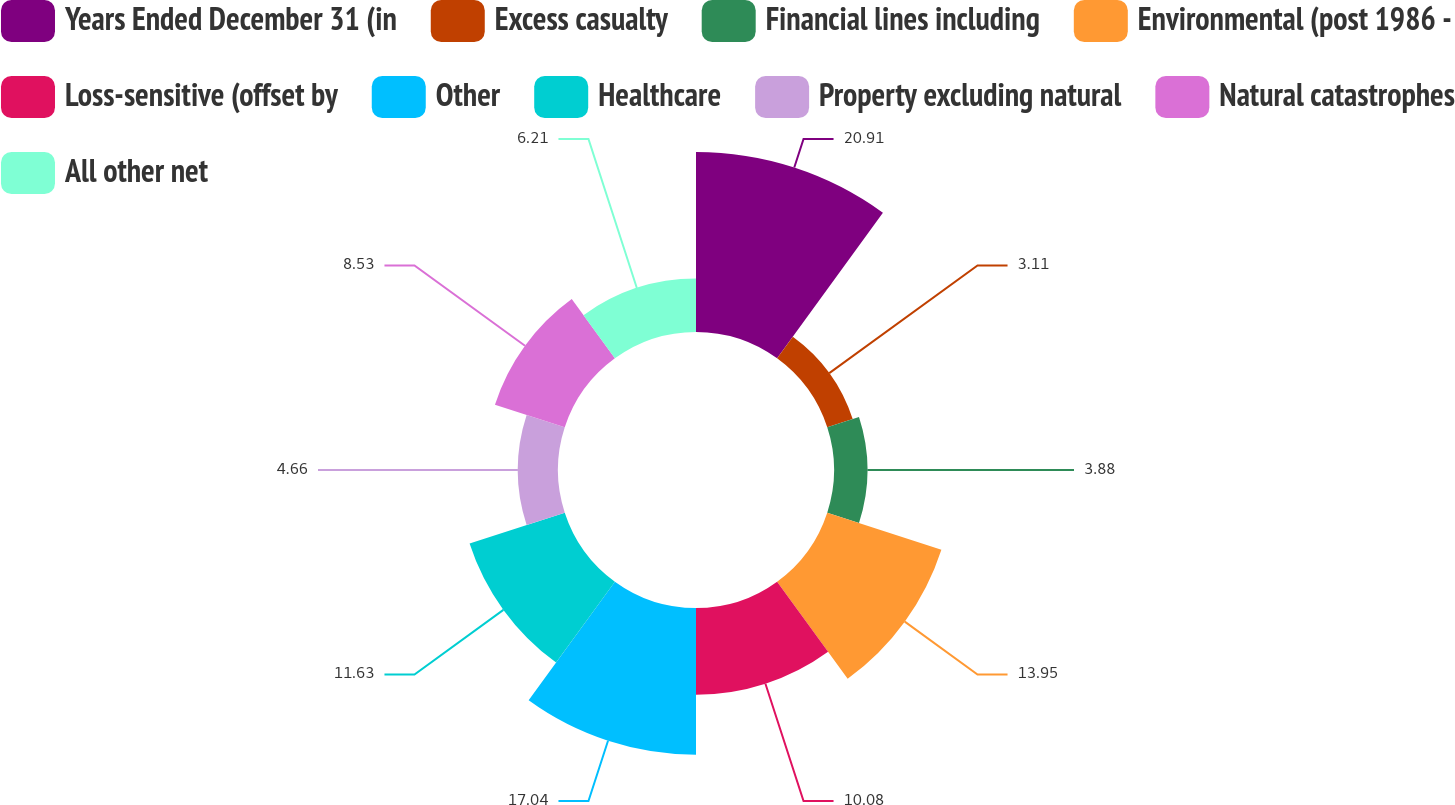<chart> <loc_0><loc_0><loc_500><loc_500><pie_chart><fcel>Years Ended December 31 (in<fcel>Excess casualty<fcel>Financial lines including<fcel>Environmental (post 1986 -<fcel>Loss-sensitive (offset by<fcel>Other<fcel>Healthcare<fcel>Property excluding natural<fcel>Natural catastrophes<fcel>All other net<nl><fcel>20.92%<fcel>3.11%<fcel>3.88%<fcel>13.95%<fcel>10.08%<fcel>17.05%<fcel>11.63%<fcel>4.66%<fcel>8.53%<fcel>6.21%<nl></chart> 